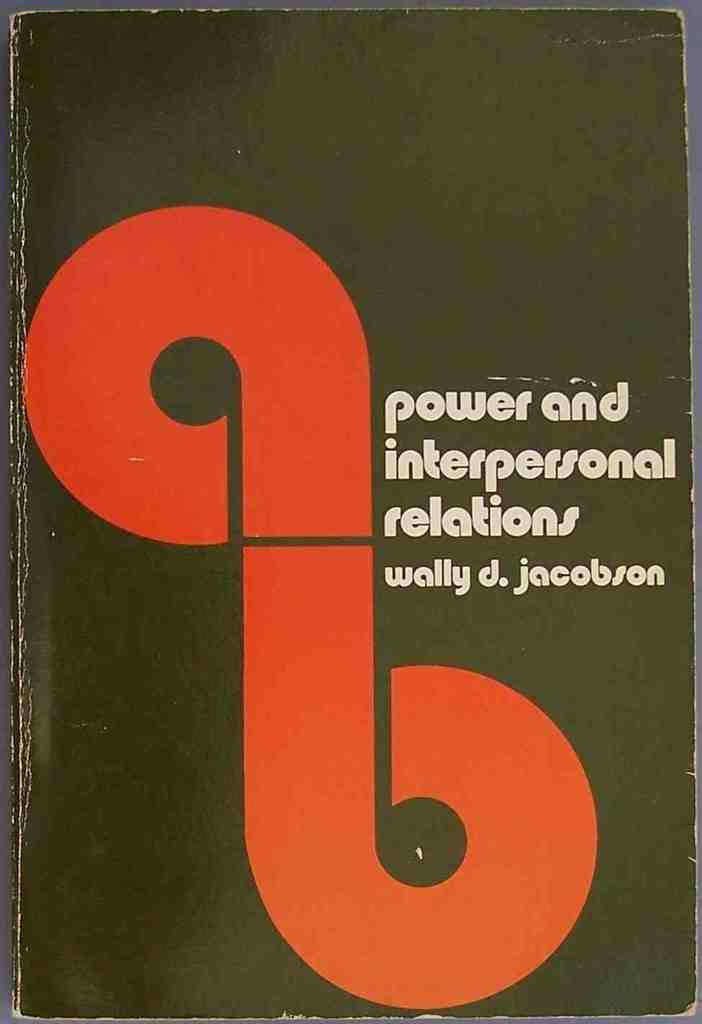What is present on the wall in the image? There is a poster in the image. What can be seen on the poster? The poster has a symbol on it and text. How many people are attending the meeting in the image? There is no meeting present in the image; it only features a poster with a symbol and text. 